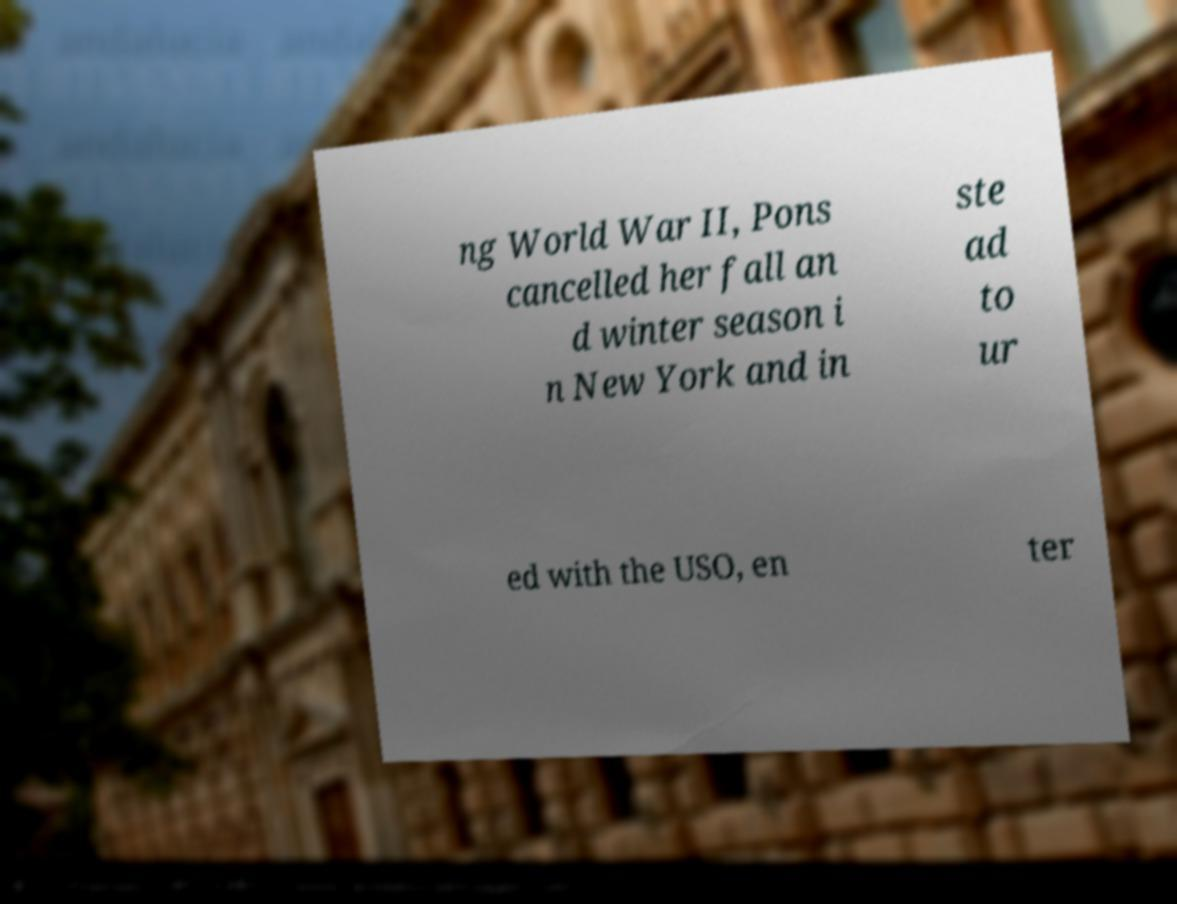Please read and relay the text visible in this image. What does it say? ng World War II, Pons cancelled her fall an d winter season i n New York and in ste ad to ur ed with the USO, en ter 